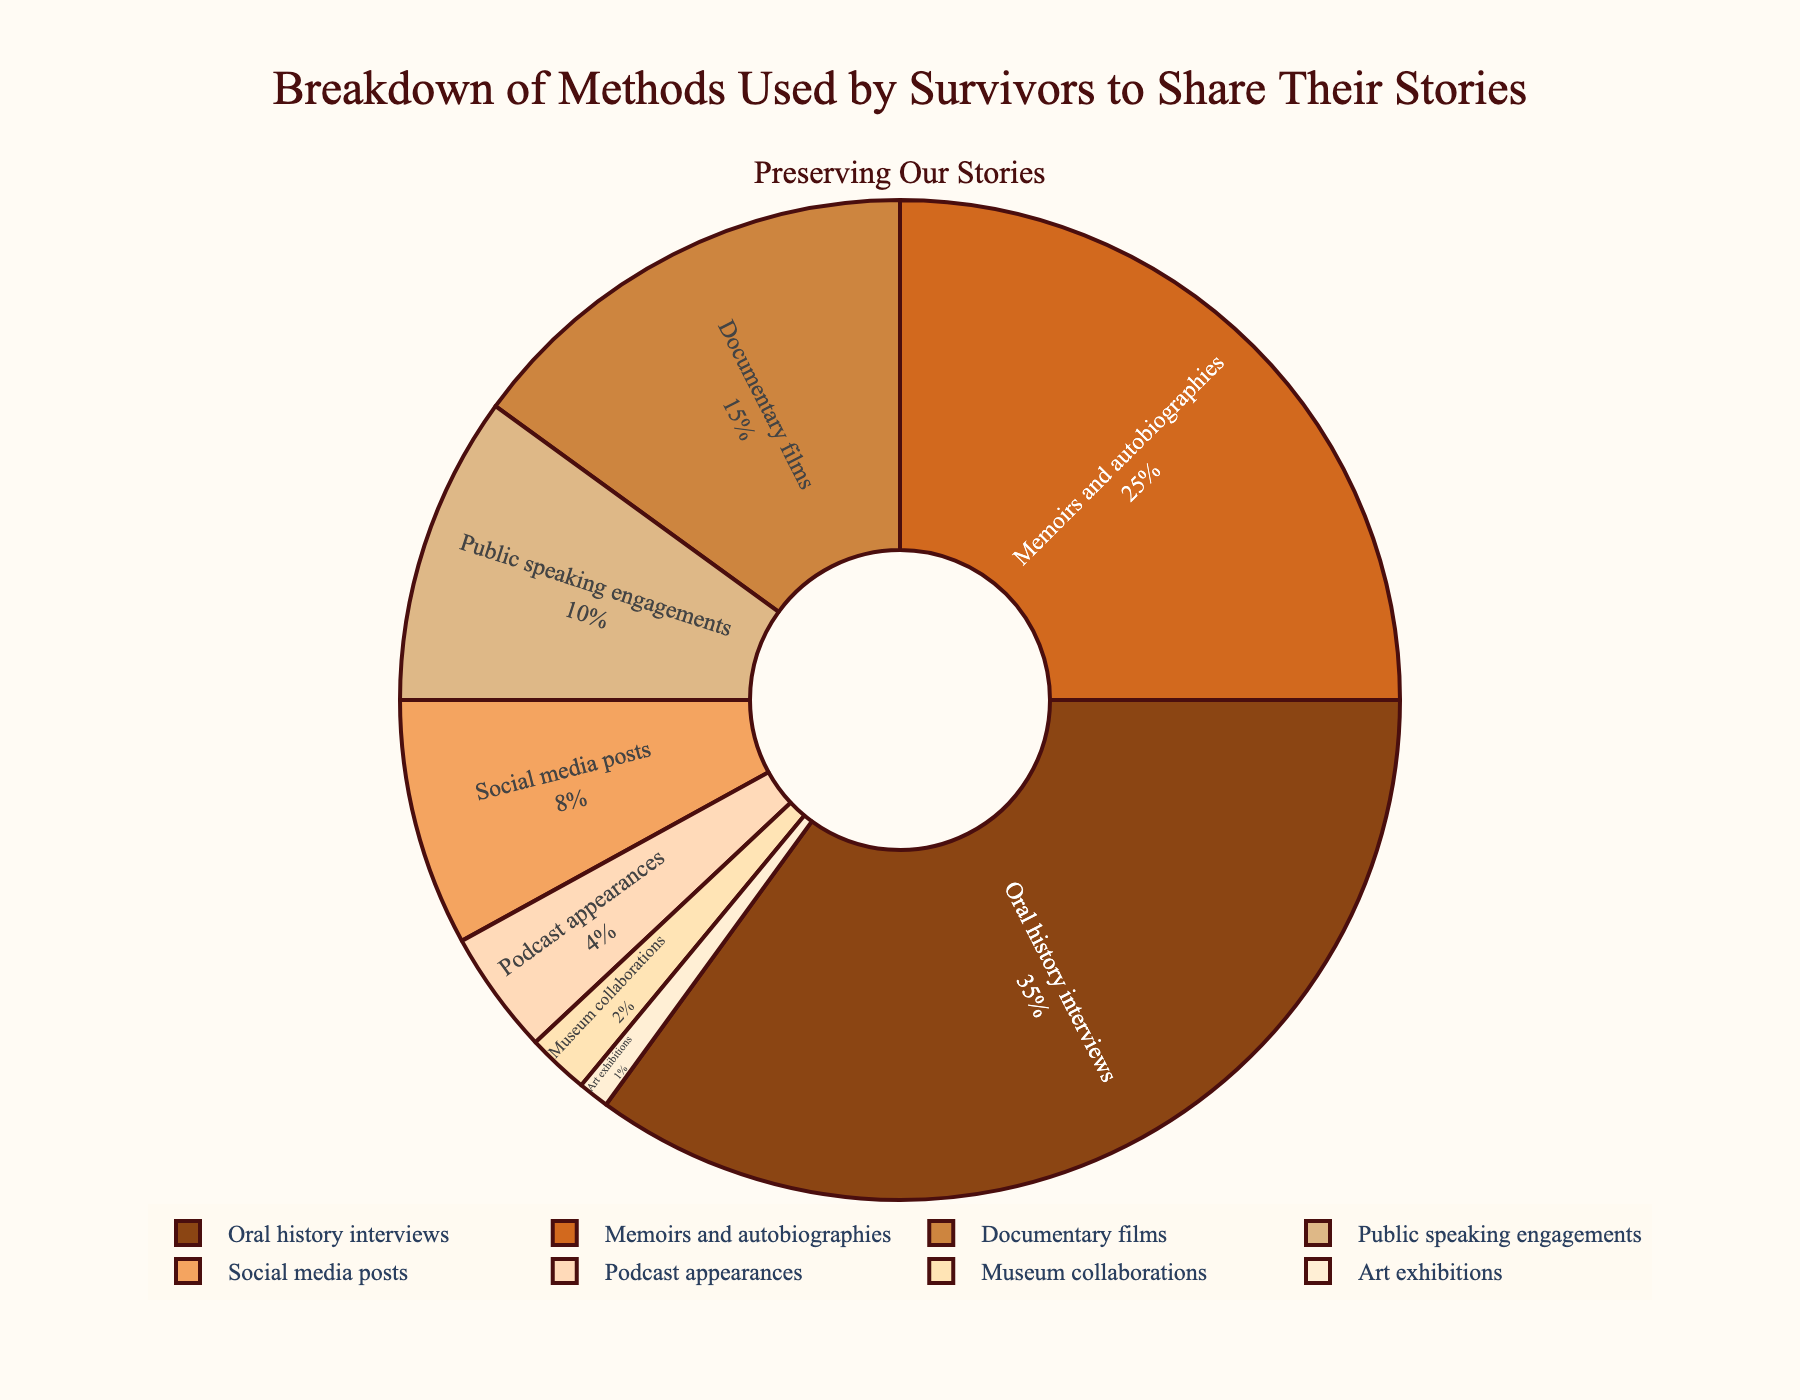What method is used by the largest number of survivors? To determine this, we look at the segment with the largest percentage in the figure. "Oral history interviews" is the method with the largest segment, which occupies 35%.
Answer: Oral history interviews Which method is used least by the survivors? The smallest segment in the figure represents the least used method. "Art exhibitions" has the smallest segment with a percentage of 1%.
Answer: Art exhibitions What is the combined percentage of methods involving media (documentary films, social media posts, and podcast appearances)? Add the percentages of "Documentary films" (15%), "Social media posts" (8%), and "Podcast appearances" (4%). The sum is 15 + 8 + 4 = 27%.
Answer: 27% How many methods are used by more than 10% of survivors? We count the segments with percentages greater than 10%. They are: Oral history interviews (35%), Memoirs and autobiographies (25%), and Documentary films (15%). There are 3 methods in total.
Answer: 3 Compare the use of public speaking engagements to social media posts. Which is more popular? To compare, we check the sizes of the segments for "Public speaking engagements" (10%) and "Social media posts" (8%). Public speaking engagements have a larger percentage.
Answer: Public speaking engagements What is the total percentage of methods that are used by exactly 4% or fewer survivors? Sum the percentages of "Podcast appearances" (4%), "Museum collaborations" (2%), and "Art exhibitions" (1%). The total is 4 + 2 + 1 = 7%.
Answer: 7% Are memoirs and autobiographies used more often than documentary films? Compare the segments of "Memoirs and autobiographies" (25%) and "Documentary films" (15%). Memoirs and autobiographies are used more often.
Answer: Yes Which method, not including the top three, has the highest usage percentage? Excluding "Oral history interviews" (35%), "Memoirs and autobiographies" (25%), and "Documentary films" (15%), the next highest segment is "Public speaking engagements" with 10%.
Answer: Public speaking engagements Which methods collectively make up less than 10% of usage? To find this, sum the segments of "Podcast appearances" (4%), "Museum collaborations" (2%), and "Art exhibitions" (1%), which collectively make up 7%. This is less than 10%.
Answer: Podcast appearances, Museum collaborations, Art exhibitions 